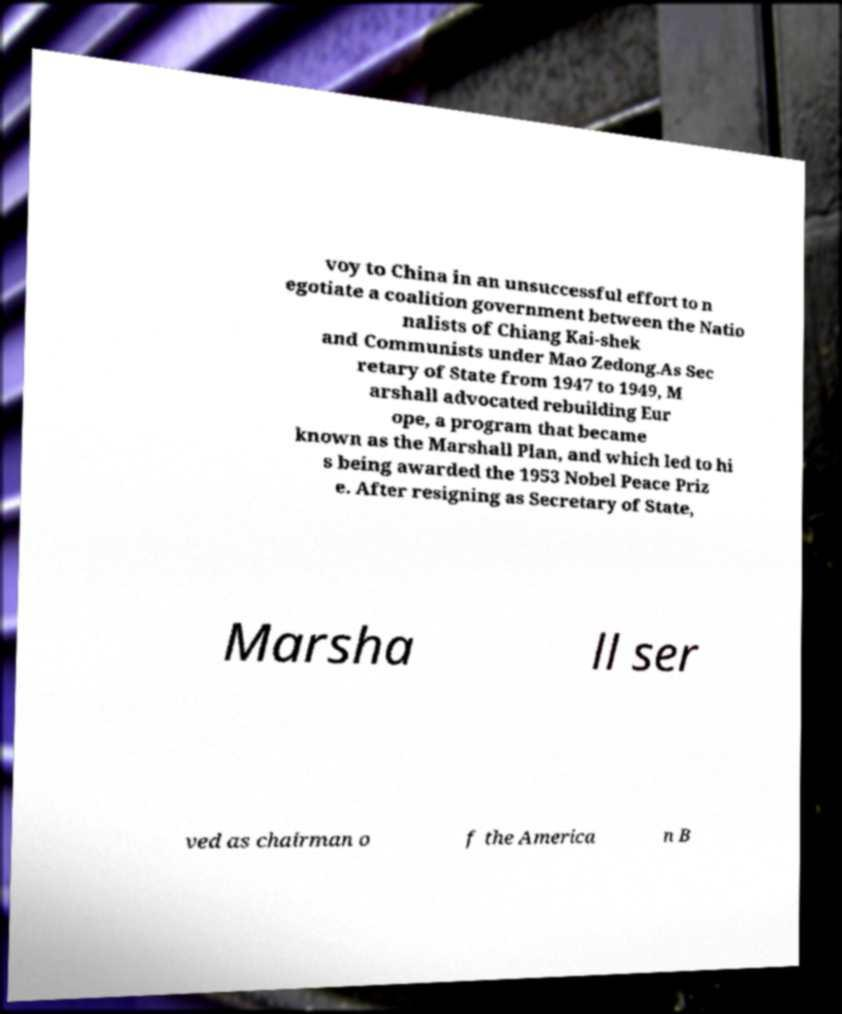For documentation purposes, I need the text within this image transcribed. Could you provide that? voy to China in an unsuccessful effort to n egotiate a coalition government between the Natio nalists of Chiang Kai-shek and Communists under Mao Zedong.As Sec retary of State from 1947 to 1949, M arshall advocated rebuilding Eur ope, a program that became known as the Marshall Plan, and which led to hi s being awarded the 1953 Nobel Peace Priz e. After resigning as Secretary of State, Marsha ll ser ved as chairman o f the America n B 